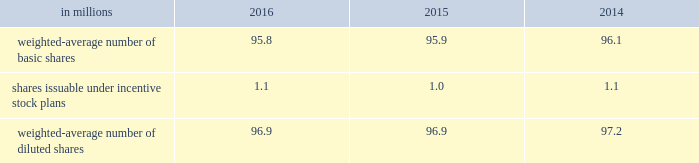The table summarizes the weighted-average number of ordinary shares outstanding for basic and diluted earnings per share calculations. .
At december 31 , 2016 , 0.6 million stock options were excluded from the computation of weighted average diluted shares outstanding because the effect of including these shares would have been anti-dilutive .
Note 21 2013 commitments and contingencies the company is involved in various litigations , claims and administrative proceedings , including those related to environmental and product warranty matters .
Amounts recorded for identified contingent liabilities are estimates , which are reviewed periodically and adjusted to reflect additional information when it becomes available .
Subject to the uncertainties inherent in estimating future costs for contingent liabilities , except as expressly set forth in this note , management believes that any liability which may result from these legal matters would not have a material adverse effect on the financial condition , results of operations , liquidity or cash flows of the company .
Environmental matters the company is dedicated to an environmental program to reduce the utilization and generation of hazardous materials during the manufacturing process and to remediate identified environmental concerns .
As to the latter , the company is currently engaged in site investigations and remediation activities to address environmental cleanup from past operations at current and former production facilities .
The company regularly evaluates its remediation programs and considers alternative remediation methods that are in addition to , or in replacement of , those currently utilized by the company based upon enhanced technology and regulatory changes .
Changes to the company's remediation programs may result in increased expenses and increased environmental reserves .
The company is sometimes a party to environmental lawsuits and claims and has received notices of potential violations of environmental laws and regulations from the u.s .
Environmental protection agency and similar state authorities .
It has also been identified as a potentially responsible party ( "prp" ) for cleanup costs associated with off-site waste disposal at federal superfund and state remediation sites .
For all such sites , there are other prps and , in most instances , the company 2019s involvement is minimal .
In estimating its liability , the company has assumed it will not bear the entire cost of remediation of any site to the exclusion of other prps who may be jointly and severally liable .
The ability of other prps to participate has been taken into account , based on our understanding of the parties 2019 financial condition and probable contributions on a per site basis .
Additional lawsuits and claims involving environmental matters are likely to arise from time to time in the future .
The company incurred $ 23.3 million , $ 4.4 million , and $ 2.9 million of expenses during the years ended december 31 , 2016 , 2015 and 2014 , respectively , for environmental remediation at sites presently or formerly owned or leased by the company .
In the fourth-quarter of 2016 , with the collaboration and approval of state regulators , the company launched a proactive , alternative approach to remediate two sites in the united states .
This approach will allow the company to more aggressively address environmental conditions at these sites and reduce the impact of potential changes in regulatory requirements .
As a result , the company recorded a $ 15 million charge for environmental remediation in the fourth quarter .
Environmental remediation costs are recorded in costs of goods sold within the consolidated statements of comprehensive income .
As of december 31 , 2016 and 2015 , the company has recorded reserves for environmental matters of $ 30.6 million and $ 15.2 million .
The total reserve at december 31 , 2016 and 2015 included $ 9.6 million and $ 2.8 million related to remediation of sites previously disposed by the company .
Environmental reserves are classified as accrued expenses and other current liabilities or other noncurrent liabilities based on their expected term .
The company's total current environmental reserve at december 31 , 2016 and 2015 was $ 6.1 million and $ 3.7 million and the remainder is classified as noncurrent .
Given the evolving nature of environmental laws , regulations and technology , the ultimate cost of future compliance is uncertain .
Warranty liability standard product warranty accruals are recorded at the time of sale and are estimated based upon product warranty terms and historical experience .
The company assesses the adequacy of its liabilities and will make adjustments as necessary based on known or anticipated warranty claims , or as new information becomes available. .
Considering the year 2016 , what is the percentage of stock options that were excluded from the computation due to its anti-dilutive effect? 
Rationale: it is the number of stocks that were excluded divided by the total number of weighted average diluted shares , then turned into a percentage .
Computations: (0.6 / 96.9)
Answer: 0.00619. 